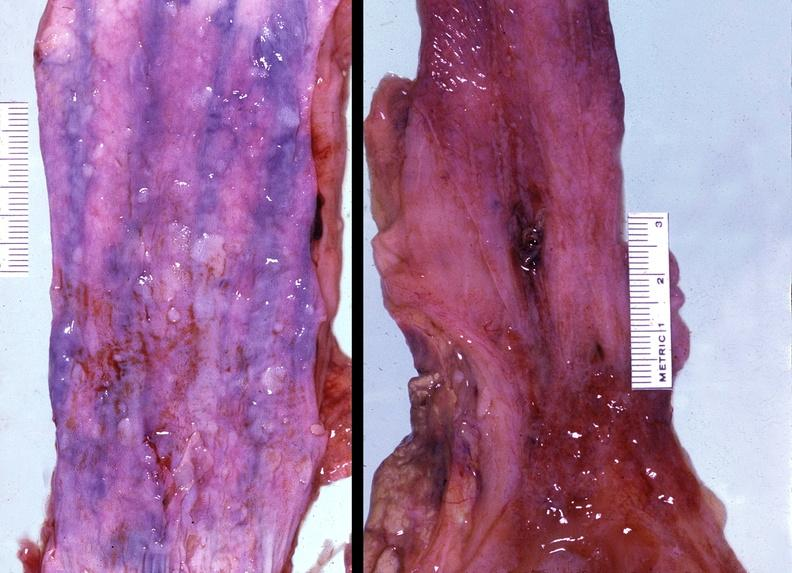what does this image show?
Answer the question using a single word or phrase. Esophagus 